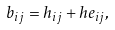<formula> <loc_0><loc_0><loc_500><loc_500>b _ { i j } = h _ { i j } + h e _ { i j } ,</formula> 